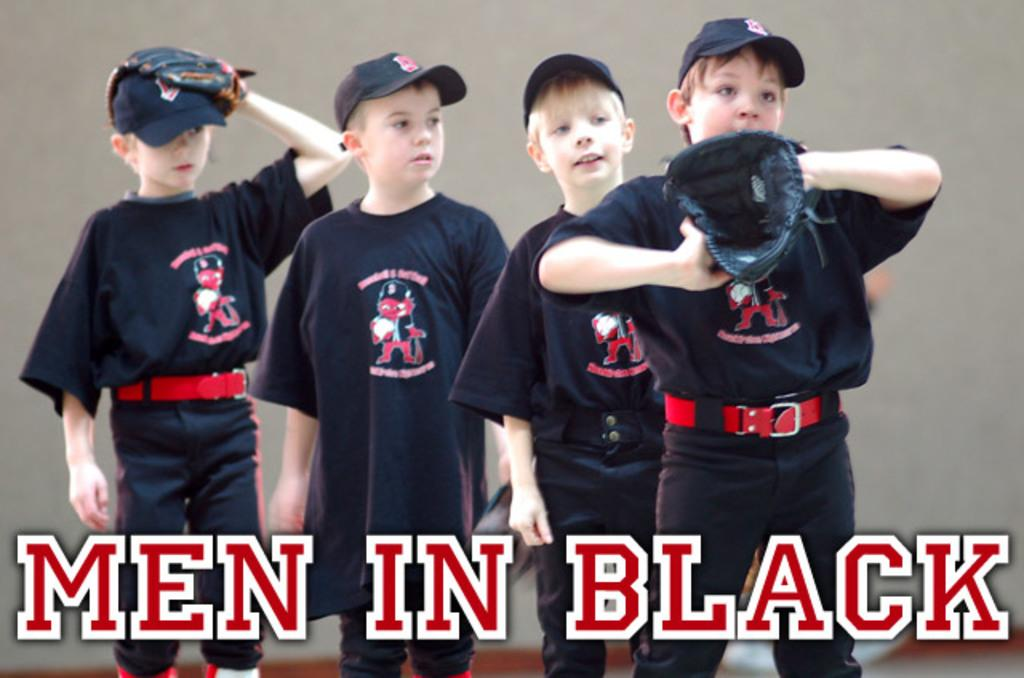<image>
Create a compact narrative representing the image presented. a group of 4 young boy baseball players labeled men in black 